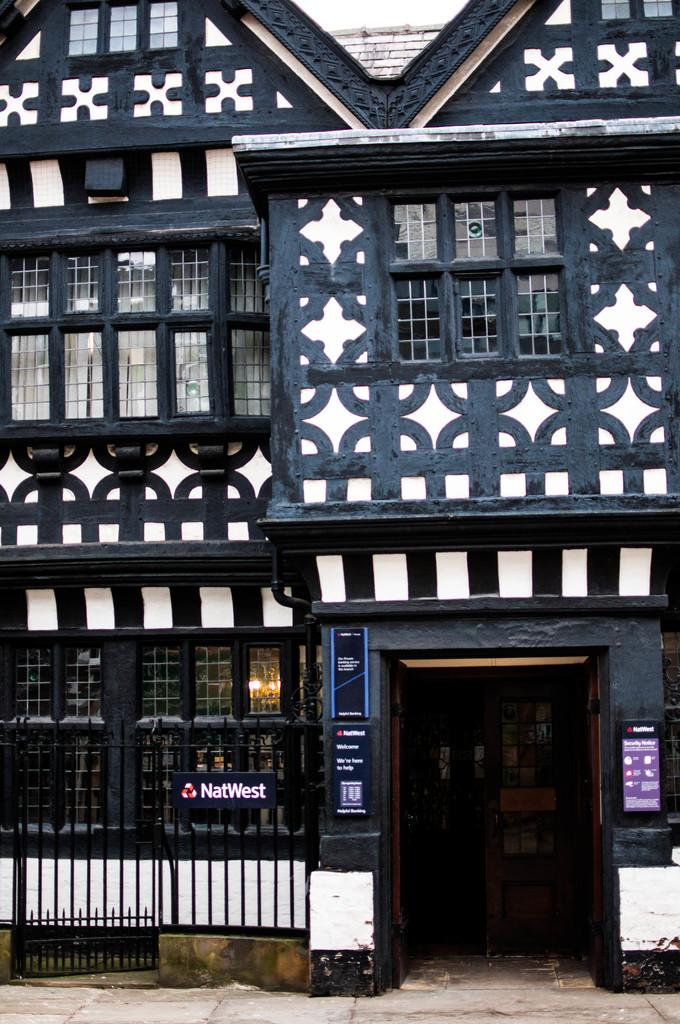What type of structure is visible in the image? There is a building in the image. What can be seen on the wall of the building? There are boards on the wall of the building. What type of door is present in the image? There is a wooden door in the image. What type of fence is visible in the image? There is a metal fence in the image. How many cherries are hanging from the metal fence in the image? There are no cherries present in the image; it only features a building, boards on the wall, a wooden door, and a metal fence. 